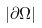<formula> <loc_0><loc_0><loc_500><loc_500>| \partial \Omega |</formula> 